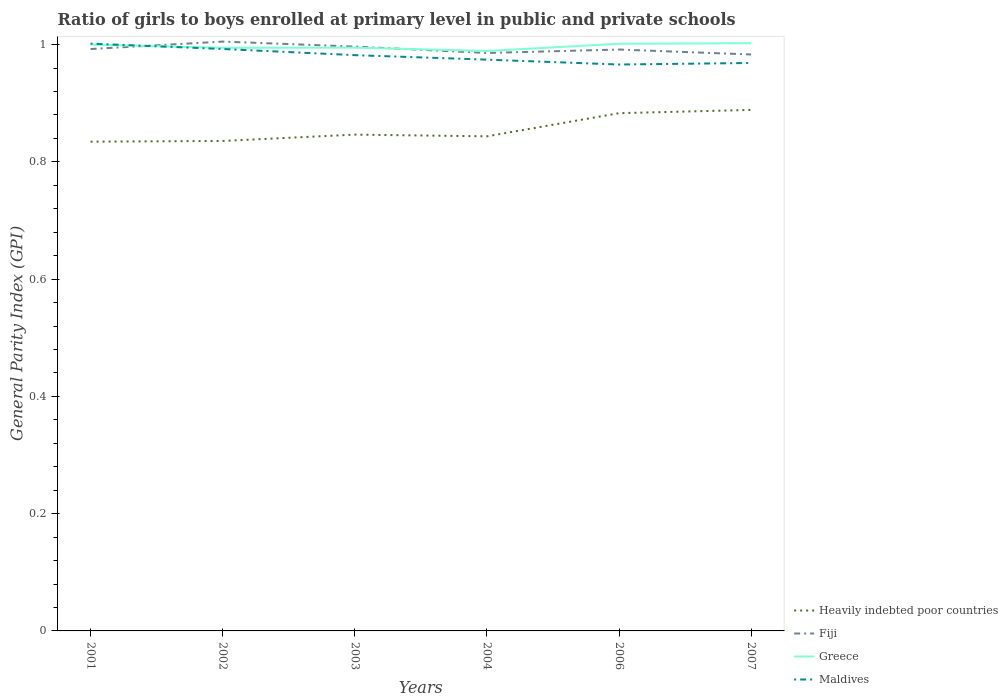Does the line corresponding to Maldives intersect with the line corresponding to Heavily indebted poor countries?
Provide a short and direct response. No. Is the number of lines equal to the number of legend labels?
Your answer should be very brief. Yes. Across all years, what is the maximum general parity index in Maldives?
Offer a very short reply. 0.97. What is the total general parity index in Heavily indebted poor countries in the graph?
Your answer should be compact. -0.01. What is the difference between the highest and the second highest general parity index in Fiji?
Offer a terse response. 0.02. What is the difference between two consecutive major ticks on the Y-axis?
Your answer should be very brief. 0.2. Does the graph contain any zero values?
Make the answer very short. No. Does the graph contain grids?
Offer a very short reply. No. Where does the legend appear in the graph?
Make the answer very short. Bottom right. How many legend labels are there?
Keep it short and to the point. 4. What is the title of the graph?
Provide a succinct answer. Ratio of girls to boys enrolled at primary level in public and private schools. Does "Saudi Arabia" appear as one of the legend labels in the graph?
Keep it short and to the point. No. What is the label or title of the Y-axis?
Your response must be concise. General Parity Index (GPI). What is the General Parity Index (GPI) of Heavily indebted poor countries in 2001?
Provide a succinct answer. 0.83. What is the General Parity Index (GPI) in Fiji in 2001?
Keep it short and to the point. 0.99. What is the General Parity Index (GPI) in Greece in 2001?
Provide a short and direct response. 1. What is the General Parity Index (GPI) in Maldives in 2001?
Provide a succinct answer. 1. What is the General Parity Index (GPI) of Heavily indebted poor countries in 2002?
Ensure brevity in your answer.  0.84. What is the General Parity Index (GPI) of Fiji in 2002?
Provide a succinct answer. 1.01. What is the General Parity Index (GPI) of Greece in 2002?
Your response must be concise. 0.99. What is the General Parity Index (GPI) of Maldives in 2002?
Your answer should be very brief. 0.99. What is the General Parity Index (GPI) of Heavily indebted poor countries in 2003?
Keep it short and to the point. 0.85. What is the General Parity Index (GPI) of Fiji in 2003?
Provide a short and direct response. 1. What is the General Parity Index (GPI) in Greece in 2003?
Provide a short and direct response. 0.99. What is the General Parity Index (GPI) of Maldives in 2003?
Provide a short and direct response. 0.98. What is the General Parity Index (GPI) of Heavily indebted poor countries in 2004?
Make the answer very short. 0.84. What is the General Parity Index (GPI) in Fiji in 2004?
Provide a succinct answer. 0.99. What is the General Parity Index (GPI) in Greece in 2004?
Provide a succinct answer. 0.99. What is the General Parity Index (GPI) of Maldives in 2004?
Your answer should be compact. 0.97. What is the General Parity Index (GPI) of Heavily indebted poor countries in 2006?
Your answer should be compact. 0.88. What is the General Parity Index (GPI) in Fiji in 2006?
Your answer should be very brief. 0.99. What is the General Parity Index (GPI) in Greece in 2006?
Provide a short and direct response. 1. What is the General Parity Index (GPI) of Maldives in 2006?
Offer a very short reply. 0.97. What is the General Parity Index (GPI) in Heavily indebted poor countries in 2007?
Provide a succinct answer. 0.89. What is the General Parity Index (GPI) in Fiji in 2007?
Your response must be concise. 0.98. What is the General Parity Index (GPI) in Greece in 2007?
Give a very brief answer. 1. What is the General Parity Index (GPI) of Maldives in 2007?
Give a very brief answer. 0.97. Across all years, what is the maximum General Parity Index (GPI) in Heavily indebted poor countries?
Offer a terse response. 0.89. Across all years, what is the maximum General Parity Index (GPI) of Fiji?
Your answer should be compact. 1.01. Across all years, what is the maximum General Parity Index (GPI) of Greece?
Offer a very short reply. 1. Across all years, what is the maximum General Parity Index (GPI) of Maldives?
Your response must be concise. 1. Across all years, what is the minimum General Parity Index (GPI) of Heavily indebted poor countries?
Make the answer very short. 0.83. Across all years, what is the minimum General Parity Index (GPI) of Fiji?
Provide a succinct answer. 0.98. Across all years, what is the minimum General Parity Index (GPI) in Greece?
Give a very brief answer. 0.99. Across all years, what is the minimum General Parity Index (GPI) of Maldives?
Give a very brief answer. 0.97. What is the total General Parity Index (GPI) in Heavily indebted poor countries in the graph?
Keep it short and to the point. 5.13. What is the total General Parity Index (GPI) in Fiji in the graph?
Offer a terse response. 5.95. What is the total General Parity Index (GPI) of Greece in the graph?
Make the answer very short. 5.98. What is the total General Parity Index (GPI) of Maldives in the graph?
Provide a short and direct response. 5.89. What is the difference between the General Parity Index (GPI) of Heavily indebted poor countries in 2001 and that in 2002?
Offer a very short reply. -0. What is the difference between the General Parity Index (GPI) in Fiji in 2001 and that in 2002?
Your answer should be very brief. -0.01. What is the difference between the General Parity Index (GPI) in Greece in 2001 and that in 2002?
Ensure brevity in your answer.  0.01. What is the difference between the General Parity Index (GPI) of Maldives in 2001 and that in 2002?
Provide a succinct answer. 0.01. What is the difference between the General Parity Index (GPI) of Heavily indebted poor countries in 2001 and that in 2003?
Offer a terse response. -0.01. What is the difference between the General Parity Index (GPI) in Fiji in 2001 and that in 2003?
Your answer should be very brief. -0. What is the difference between the General Parity Index (GPI) of Greece in 2001 and that in 2003?
Provide a succinct answer. 0.01. What is the difference between the General Parity Index (GPI) in Maldives in 2001 and that in 2003?
Your answer should be compact. 0.02. What is the difference between the General Parity Index (GPI) of Heavily indebted poor countries in 2001 and that in 2004?
Provide a succinct answer. -0.01. What is the difference between the General Parity Index (GPI) in Fiji in 2001 and that in 2004?
Your answer should be very brief. 0.01. What is the difference between the General Parity Index (GPI) in Greece in 2001 and that in 2004?
Provide a succinct answer. 0.01. What is the difference between the General Parity Index (GPI) of Maldives in 2001 and that in 2004?
Provide a short and direct response. 0.03. What is the difference between the General Parity Index (GPI) of Heavily indebted poor countries in 2001 and that in 2006?
Give a very brief answer. -0.05. What is the difference between the General Parity Index (GPI) in Fiji in 2001 and that in 2006?
Offer a very short reply. 0. What is the difference between the General Parity Index (GPI) in Greece in 2001 and that in 2006?
Provide a succinct answer. -0. What is the difference between the General Parity Index (GPI) of Maldives in 2001 and that in 2006?
Your answer should be very brief. 0.04. What is the difference between the General Parity Index (GPI) of Heavily indebted poor countries in 2001 and that in 2007?
Provide a short and direct response. -0.05. What is the difference between the General Parity Index (GPI) of Fiji in 2001 and that in 2007?
Provide a succinct answer. 0.01. What is the difference between the General Parity Index (GPI) in Greece in 2001 and that in 2007?
Provide a succinct answer. -0. What is the difference between the General Parity Index (GPI) in Maldives in 2001 and that in 2007?
Provide a short and direct response. 0.03. What is the difference between the General Parity Index (GPI) in Heavily indebted poor countries in 2002 and that in 2003?
Offer a terse response. -0.01. What is the difference between the General Parity Index (GPI) in Fiji in 2002 and that in 2003?
Ensure brevity in your answer.  0.01. What is the difference between the General Parity Index (GPI) in Greece in 2002 and that in 2003?
Provide a succinct answer. -0. What is the difference between the General Parity Index (GPI) in Maldives in 2002 and that in 2003?
Provide a short and direct response. 0.01. What is the difference between the General Parity Index (GPI) of Heavily indebted poor countries in 2002 and that in 2004?
Offer a very short reply. -0.01. What is the difference between the General Parity Index (GPI) of Fiji in 2002 and that in 2004?
Your response must be concise. 0.02. What is the difference between the General Parity Index (GPI) of Greece in 2002 and that in 2004?
Make the answer very short. 0.01. What is the difference between the General Parity Index (GPI) in Maldives in 2002 and that in 2004?
Make the answer very short. 0.02. What is the difference between the General Parity Index (GPI) in Heavily indebted poor countries in 2002 and that in 2006?
Your response must be concise. -0.05. What is the difference between the General Parity Index (GPI) in Fiji in 2002 and that in 2006?
Offer a very short reply. 0.01. What is the difference between the General Parity Index (GPI) in Greece in 2002 and that in 2006?
Make the answer very short. -0.01. What is the difference between the General Parity Index (GPI) in Maldives in 2002 and that in 2006?
Your response must be concise. 0.03. What is the difference between the General Parity Index (GPI) of Heavily indebted poor countries in 2002 and that in 2007?
Keep it short and to the point. -0.05. What is the difference between the General Parity Index (GPI) of Fiji in 2002 and that in 2007?
Provide a succinct answer. 0.02. What is the difference between the General Parity Index (GPI) in Greece in 2002 and that in 2007?
Keep it short and to the point. -0.01. What is the difference between the General Parity Index (GPI) in Maldives in 2002 and that in 2007?
Provide a succinct answer. 0.02. What is the difference between the General Parity Index (GPI) in Heavily indebted poor countries in 2003 and that in 2004?
Give a very brief answer. 0. What is the difference between the General Parity Index (GPI) in Fiji in 2003 and that in 2004?
Ensure brevity in your answer.  0.01. What is the difference between the General Parity Index (GPI) in Greece in 2003 and that in 2004?
Offer a terse response. 0.01. What is the difference between the General Parity Index (GPI) in Maldives in 2003 and that in 2004?
Your response must be concise. 0.01. What is the difference between the General Parity Index (GPI) of Heavily indebted poor countries in 2003 and that in 2006?
Ensure brevity in your answer.  -0.04. What is the difference between the General Parity Index (GPI) of Fiji in 2003 and that in 2006?
Your answer should be very brief. 0.01. What is the difference between the General Parity Index (GPI) of Greece in 2003 and that in 2006?
Give a very brief answer. -0.01. What is the difference between the General Parity Index (GPI) of Maldives in 2003 and that in 2006?
Your answer should be compact. 0.02. What is the difference between the General Parity Index (GPI) in Heavily indebted poor countries in 2003 and that in 2007?
Make the answer very short. -0.04. What is the difference between the General Parity Index (GPI) of Fiji in 2003 and that in 2007?
Your answer should be very brief. 0.01. What is the difference between the General Parity Index (GPI) of Greece in 2003 and that in 2007?
Keep it short and to the point. -0.01. What is the difference between the General Parity Index (GPI) in Maldives in 2003 and that in 2007?
Give a very brief answer. 0.01. What is the difference between the General Parity Index (GPI) in Heavily indebted poor countries in 2004 and that in 2006?
Make the answer very short. -0.04. What is the difference between the General Parity Index (GPI) in Fiji in 2004 and that in 2006?
Offer a terse response. -0.01. What is the difference between the General Parity Index (GPI) in Greece in 2004 and that in 2006?
Make the answer very short. -0.01. What is the difference between the General Parity Index (GPI) of Maldives in 2004 and that in 2006?
Your answer should be very brief. 0.01. What is the difference between the General Parity Index (GPI) in Heavily indebted poor countries in 2004 and that in 2007?
Offer a terse response. -0.05. What is the difference between the General Parity Index (GPI) in Fiji in 2004 and that in 2007?
Offer a very short reply. 0. What is the difference between the General Parity Index (GPI) of Greece in 2004 and that in 2007?
Your answer should be very brief. -0.01. What is the difference between the General Parity Index (GPI) of Maldives in 2004 and that in 2007?
Your response must be concise. 0.01. What is the difference between the General Parity Index (GPI) in Heavily indebted poor countries in 2006 and that in 2007?
Offer a very short reply. -0.01. What is the difference between the General Parity Index (GPI) in Fiji in 2006 and that in 2007?
Make the answer very short. 0.01. What is the difference between the General Parity Index (GPI) of Greece in 2006 and that in 2007?
Offer a terse response. -0. What is the difference between the General Parity Index (GPI) in Maldives in 2006 and that in 2007?
Provide a short and direct response. -0. What is the difference between the General Parity Index (GPI) of Heavily indebted poor countries in 2001 and the General Parity Index (GPI) of Fiji in 2002?
Make the answer very short. -0.17. What is the difference between the General Parity Index (GPI) in Heavily indebted poor countries in 2001 and the General Parity Index (GPI) in Greece in 2002?
Give a very brief answer. -0.16. What is the difference between the General Parity Index (GPI) in Heavily indebted poor countries in 2001 and the General Parity Index (GPI) in Maldives in 2002?
Offer a very short reply. -0.16. What is the difference between the General Parity Index (GPI) of Fiji in 2001 and the General Parity Index (GPI) of Greece in 2002?
Offer a terse response. -0. What is the difference between the General Parity Index (GPI) in Fiji in 2001 and the General Parity Index (GPI) in Maldives in 2002?
Provide a short and direct response. -0. What is the difference between the General Parity Index (GPI) in Greece in 2001 and the General Parity Index (GPI) in Maldives in 2002?
Provide a short and direct response. 0.01. What is the difference between the General Parity Index (GPI) in Heavily indebted poor countries in 2001 and the General Parity Index (GPI) in Fiji in 2003?
Offer a terse response. -0.16. What is the difference between the General Parity Index (GPI) in Heavily indebted poor countries in 2001 and the General Parity Index (GPI) in Greece in 2003?
Provide a short and direct response. -0.16. What is the difference between the General Parity Index (GPI) of Heavily indebted poor countries in 2001 and the General Parity Index (GPI) of Maldives in 2003?
Ensure brevity in your answer.  -0.15. What is the difference between the General Parity Index (GPI) of Fiji in 2001 and the General Parity Index (GPI) of Greece in 2003?
Offer a very short reply. -0. What is the difference between the General Parity Index (GPI) in Fiji in 2001 and the General Parity Index (GPI) in Maldives in 2003?
Offer a very short reply. 0.01. What is the difference between the General Parity Index (GPI) in Greece in 2001 and the General Parity Index (GPI) in Maldives in 2003?
Keep it short and to the point. 0.02. What is the difference between the General Parity Index (GPI) of Heavily indebted poor countries in 2001 and the General Parity Index (GPI) of Fiji in 2004?
Give a very brief answer. -0.15. What is the difference between the General Parity Index (GPI) in Heavily indebted poor countries in 2001 and the General Parity Index (GPI) in Greece in 2004?
Keep it short and to the point. -0.15. What is the difference between the General Parity Index (GPI) of Heavily indebted poor countries in 2001 and the General Parity Index (GPI) of Maldives in 2004?
Provide a succinct answer. -0.14. What is the difference between the General Parity Index (GPI) of Fiji in 2001 and the General Parity Index (GPI) of Greece in 2004?
Make the answer very short. 0. What is the difference between the General Parity Index (GPI) in Fiji in 2001 and the General Parity Index (GPI) in Maldives in 2004?
Your answer should be very brief. 0.02. What is the difference between the General Parity Index (GPI) of Greece in 2001 and the General Parity Index (GPI) of Maldives in 2004?
Ensure brevity in your answer.  0.03. What is the difference between the General Parity Index (GPI) of Heavily indebted poor countries in 2001 and the General Parity Index (GPI) of Fiji in 2006?
Provide a succinct answer. -0.16. What is the difference between the General Parity Index (GPI) of Heavily indebted poor countries in 2001 and the General Parity Index (GPI) of Greece in 2006?
Your response must be concise. -0.17. What is the difference between the General Parity Index (GPI) of Heavily indebted poor countries in 2001 and the General Parity Index (GPI) of Maldives in 2006?
Offer a terse response. -0.13. What is the difference between the General Parity Index (GPI) of Fiji in 2001 and the General Parity Index (GPI) of Greece in 2006?
Make the answer very short. -0.01. What is the difference between the General Parity Index (GPI) in Fiji in 2001 and the General Parity Index (GPI) in Maldives in 2006?
Provide a succinct answer. 0.03. What is the difference between the General Parity Index (GPI) in Greece in 2001 and the General Parity Index (GPI) in Maldives in 2006?
Keep it short and to the point. 0.03. What is the difference between the General Parity Index (GPI) of Heavily indebted poor countries in 2001 and the General Parity Index (GPI) of Fiji in 2007?
Your answer should be very brief. -0.15. What is the difference between the General Parity Index (GPI) in Heavily indebted poor countries in 2001 and the General Parity Index (GPI) in Greece in 2007?
Provide a succinct answer. -0.17. What is the difference between the General Parity Index (GPI) of Heavily indebted poor countries in 2001 and the General Parity Index (GPI) of Maldives in 2007?
Your answer should be compact. -0.13. What is the difference between the General Parity Index (GPI) of Fiji in 2001 and the General Parity Index (GPI) of Greece in 2007?
Offer a very short reply. -0.01. What is the difference between the General Parity Index (GPI) in Fiji in 2001 and the General Parity Index (GPI) in Maldives in 2007?
Give a very brief answer. 0.02. What is the difference between the General Parity Index (GPI) of Greece in 2001 and the General Parity Index (GPI) of Maldives in 2007?
Keep it short and to the point. 0.03. What is the difference between the General Parity Index (GPI) in Heavily indebted poor countries in 2002 and the General Parity Index (GPI) in Fiji in 2003?
Keep it short and to the point. -0.16. What is the difference between the General Parity Index (GPI) of Heavily indebted poor countries in 2002 and the General Parity Index (GPI) of Greece in 2003?
Offer a terse response. -0.16. What is the difference between the General Parity Index (GPI) of Heavily indebted poor countries in 2002 and the General Parity Index (GPI) of Maldives in 2003?
Offer a terse response. -0.15. What is the difference between the General Parity Index (GPI) in Fiji in 2002 and the General Parity Index (GPI) in Greece in 2003?
Offer a terse response. 0.01. What is the difference between the General Parity Index (GPI) of Fiji in 2002 and the General Parity Index (GPI) of Maldives in 2003?
Your answer should be very brief. 0.02. What is the difference between the General Parity Index (GPI) in Greece in 2002 and the General Parity Index (GPI) in Maldives in 2003?
Offer a very short reply. 0.01. What is the difference between the General Parity Index (GPI) in Heavily indebted poor countries in 2002 and the General Parity Index (GPI) in Fiji in 2004?
Your answer should be very brief. -0.15. What is the difference between the General Parity Index (GPI) in Heavily indebted poor countries in 2002 and the General Parity Index (GPI) in Greece in 2004?
Give a very brief answer. -0.15. What is the difference between the General Parity Index (GPI) in Heavily indebted poor countries in 2002 and the General Parity Index (GPI) in Maldives in 2004?
Ensure brevity in your answer.  -0.14. What is the difference between the General Parity Index (GPI) of Fiji in 2002 and the General Parity Index (GPI) of Greece in 2004?
Make the answer very short. 0.02. What is the difference between the General Parity Index (GPI) of Fiji in 2002 and the General Parity Index (GPI) of Maldives in 2004?
Provide a short and direct response. 0.03. What is the difference between the General Parity Index (GPI) in Greece in 2002 and the General Parity Index (GPI) in Maldives in 2004?
Ensure brevity in your answer.  0.02. What is the difference between the General Parity Index (GPI) of Heavily indebted poor countries in 2002 and the General Parity Index (GPI) of Fiji in 2006?
Offer a terse response. -0.16. What is the difference between the General Parity Index (GPI) in Heavily indebted poor countries in 2002 and the General Parity Index (GPI) in Greece in 2006?
Provide a succinct answer. -0.17. What is the difference between the General Parity Index (GPI) of Heavily indebted poor countries in 2002 and the General Parity Index (GPI) of Maldives in 2006?
Provide a succinct answer. -0.13. What is the difference between the General Parity Index (GPI) of Fiji in 2002 and the General Parity Index (GPI) of Greece in 2006?
Offer a very short reply. 0. What is the difference between the General Parity Index (GPI) of Fiji in 2002 and the General Parity Index (GPI) of Maldives in 2006?
Offer a very short reply. 0.04. What is the difference between the General Parity Index (GPI) of Greece in 2002 and the General Parity Index (GPI) of Maldives in 2006?
Ensure brevity in your answer.  0.03. What is the difference between the General Parity Index (GPI) in Heavily indebted poor countries in 2002 and the General Parity Index (GPI) in Fiji in 2007?
Offer a terse response. -0.15. What is the difference between the General Parity Index (GPI) of Heavily indebted poor countries in 2002 and the General Parity Index (GPI) of Maldives in 2007?
Your answer should be very brief. -0.13. What is the difference between the General Parity Index (GPI) in Fiji in 2002 and the General Parity Index (GPI) in Greece in 2007?
Provide a short and direct response. 0. What is the difference between the General Parity Index (GPI) in Fiji in 2002 and the General Parity Index (GPI) in Maldives in 2007?
Provide a short and direct response. 0.04. What is the difference between the General Parity Index (GPI) of Greece in 2002 and the General Parity Index (GPI) of Maldives in 2007?
Your answer should be very brief. 0.03. What is the difference between the General Parity Index (GPI) in Heavily indebted poor countries in 2003 and the General Parity Index (GPI) in Fiji in 2004?
Ensure brevity in your answer.  -0.14. What is the difference between the General Parity Index (GPI) of Heavily indebted poor countries in 2003 and the General Parity Index (GPI) of Greece in 2004?
Ensure brevity in your answer.  -0.14. What is the difference between the General Parity Index (GPI) in Heavily indebted poor countries in 2003 and the General Parity Index (GPI) in Maldives in 2004?
Keep it short and to the point. -0.13. What is the difference between the General Parity Index (GPI) of Fiji in 2003 and the General Parity Index (GPI) of Greece in 2004?
Give a very brief answer. 0.01. What is the difference between the General Parity Index (GPI) of Fiji in 2003 and the General Parity Index (GPI) of Maldives in 2004?
Offer a terse response. 0.02. What is the difference between the General Parity Index (GPI) of Greece in 2003 and the General Parity Index (GPI) of Maldives in 2004?
Your answer should be very brief. 0.02. What is the difference between the General Parity Index (GPI) in Heavily indebted poor countries in 2003 and the General Parity Index (GPI) in Fiji in 2006?
Keep it short and to the point. -0.15. What is the difference between the General Parity Index (GPI) in Heavily indebted poor countries in 2003 and the General Parity Index (GPI) in Greece in 2006?
Your answer should be very brief. -0.15. What is the difference between the General Parity Index (GPI) in Heavily indebted poor countries in 2003 and the General Parity Index (GPI) in Maldives in 2006?
Provide a succinct answer. -0.12. What is the difference between the General Parity Index (GPI) in Fiji in 2003 and the General Parity Index (GPI) in Greece in 2006?
Your response must be concise. -0. What is the difference between the General Parity Index (GPI) of Fiji in 2003 and the General Parity Index (GPI) of Maldives in 2006?
Your answer should be very brief. 0.03. What is the difference between the General Parity Index (GPI) in Greece in 2003 and the General Parity Index (GPI) in Maldives in 2006?
Ensure brevity in your answer.  0.03. What is the difference between the General Parity Index (GPI) in Heavily indebted poor countries in 2003 and the General Parity Index (GPI) in Fiji in 2007?
Ensure brevity in your answer.  -0.14. What is the difference between the General Parity Index (GPI) in Heavily indebted poor countries in 2003 and the General Parity Index (GPI) in Greece in 2007?
Ensure brevity in your answer.  -0.16. What is the difference between the General Parity Index (GPI) in Heavily indebted poor countries in 2003 and the General Parity Index (GPI) in Maldives in 2007?
Offer a very short reply. -0.12. What is the difference between the General Parity Index (GPI) in Fiji in 2003 and the General Parity Index (GPI) in Greece in 2007?
Offer a terse response. -0.01. What is the difference between the General Parity Index (GPI) in Fiji in 2003 and the General Parity Index (GPI) in Maldives in 2007?
Offer a very short reply. 0.03. What is the difference between the General Parity Index (GPI) of Greece in 2003 and the General Parity Index (GPI) of Maldives in 2007?
Make the answer very short. 0.03. What is the difference between the General Parity Index (GPI) of Heavily indebted poor countries in 2004 and the General Parity Index (GPI) of Fiji in 2006?
Give a very brief answer. -0.15. What is the difference between the General Parity Index (GPI) in Heavily indebted poor countries in 2004 and the General Parity Index (GPI) in Greece in 2006?
Give a very brief answer. -0.16. What is the difference between the General Parity Index (GPI) of Heavily indebted poor countries in 2004 and the General Parity Index (GPI) of Maldives in 2006?
Your answer should be very brief. -0.12. What is the difference between the General Parity Index (GPI) of Fiji in 2004 and the General Parity Index (GPI) of Greece in 2006?
Keep it short and to the point. -0.02. What is the difference between the General Parity Index (GPI) of Fiji in 2004 and the General Parity Index (GPI) of Maldives in 2006?
Keep it short and to the point. 0.02. What is the difference between the General Parity Index (GPI) in Greece in 2004 and the General Parity Index (GPI) in Maldives in 2006?
Your response must be concise. 0.02. What is the difference between the General Parity Index (GPI) of Heavily indebted poor countries in 2004 and the General Parity Index (GPI) of Fiji in 2007?
Provide a succinct answer. -0.14. What is the difference between the General Parity Index (GPI) in Heavily indebted poor countries in 2004 and the General Parity Index (GPI) in Greece in 2007?
Your answer should be very brief. -0.16. What is the difference between the General Parity Index (GPI) of Heavily indebted poor countries in 2004 and the General Parity Index (GPI) of Maldives in 2007?
Your answer should be compact. -0.13. What is the difference between the General Parity Index (GPI) of Fiji in 2004 and the General Parity Index (GPI) of Greece in 2007?
Keep it short and to the point. -0.02. What is the difference between the General Parity Index (GPI) in Fiji in 2004 and the General Parity Index (GPI) in Maldives in 2007?
Your answer should be compact. 0.02. What is the difference between the General Parity Index (GPI) of Greece in 2004 and the General Parity Index (GPI) of Maldives in 2007?
Offer a very short reply. 0.02. What is the difference between the General Parity Index (GPI) in Heavily indebted poor countries in 2006 and the General Parity Index (GPI) in Fiji in 2007?
Keep it short and to the point. -0.1. What is the difference between the General Parity Index (GPI) of Heavily indebted poor countries in 2006 and the General Parity Index (GPI) of Greece in 2007?
Offer a very short reply. -0.12. What is the difference between the General Parity Index (GPI) of Heavily indebted poor countries in 2006 and the General Parity Index (GPI) of Maldives in 2007?
Provide a succinct answer. -0.09. What is the difference between the General Parity Index (GPI) of Fiji in 2006 and the General Parity Index (GPI) of Greece in 2007?
Give a very brief answer. -0.01. What is the difference between the General Parity Index (GPI) in Fiji in 2006 and the General Parity Index (GPI) in Maldives in 2007?
Your answer should be compact. 0.02. What is the difference between the General Parity Index (GPI) of Greece in 2006 and the General Parity Index (GPI) of Maldives in 2007?
Offer a very short reply. 0.03. What is the average General Parity Index (GPI) of Heavily indebted poor countries per year?
Provide a short and direct response. 0.86. What is the average General Parity Index (GPI) of Fiji per year?
Provide a succinct answer. 0.99. What is the average General Parity Index (GPI) of Greece per year?
Your answer should be very brief. 1. What is the average General Parity Index (GPI) of Maldives per year?
Provide a succinct answer. 0.98. In the year 2001, what is the difference between the General Parity Index (GPI) in Heavily indebted poor countries and General Parity Index (GPI) in Fiji?
Your answer should be very brief. -0.16. In the year 2001, what is the difference between the General Parity Index (GPI) in Heavily indebted poor countries and General Parity Index (GPI) in Greece?
Provide a short and direct response. -0.17. In the year 2001, what is the difference between the General Parity Index (GPI) of Heavily indebted poor countries and General Parity Index (GPI) of Maldives?
Provide a succinct answer. -0.17. In the year 2001, what is the difference between the General Parity Index (GPI) in Fiji and General Parity Index (GPI) in Greece?
Give a very brief answer. -0.01. In the year 2001, what is the difference between the General Parity Index (GPI) in Fiji and General Parity Index (GPI) in Maldives?
Your response must be concise. -0.01. In the year 2001, what is the difference between the General Parity Index (GPI) of Greece and General Parity Index (GPI) of Maldives?
Provide a succinct answer. -0. In the year 2002, what is the difference between the General Parity Index (GPI) of Heavily indebted poor countries and General Parity Index (GPI) of Fiji?
Keep it short and to the point. -0.17. In the year 2002, what is the difference between the General Parity Index (GPI) of Heavily indebted poor countries and General Parity Index (GPI) of Greece?
Offer a terse response. -0.16. In the year 2002, what is the difference between the General Parity Index (GPI) of Heavily indebted poor countries and General Parity Index (GPI) of Maldives?
Your answer should be compact. -0.16. In the year 2002, what is the difference between the General Parity Index (GPI) of Fiji and General Parity Index (GPI) of Greece?
Your answer should be compact. 0.01. In the year 2002, what is the difference between the General Parity Index (GPI) in Fiji and General Parity Index (GPI) in Maldives?
Provide a succinct answer. 0.01. In the year 2002, what is the difference between the General Parity Index (GPI) of Greece and General Parity Index (GPI) of Maldives?
Keep it short and to the point. 0. In the year 2003, what is the difference between the General Parity Index (GPI) of Heavily indebted poor countries and General Parity Index (GPI) of Fiji?
Keep it short and to the point. -0.15. In the year 2003, what is the difference between the General Parity Index (GPI) of Heavily indebted poor countries and General Parity Index (GPI) of Greece?
Your answer should be very brief. -0.15. In the year 2003, what is the difference between the General Parity Index (GPI) in Heavily indebted poor countries and General Parity Index (GPI) in Maldives?
Ensure brevity in your answer.  -0.14. In the year 2003, what is the difference between the General Parity Index (GPI) of Fiji and General Parity Index (GPI) of Greece?
Offer a terse response. 0. In the year 2003, what is the difference between the General Parity Index (GPI) in Fiji and General Parity Index (GPI) in Maldives?
Your response must be concise. 0.01. In the year 2003, what is the difference between the General Parity Index (GPI) in Greece and General Parity Index (GPI) in Maldives?
Your answer should be compact. 0.01. In the year 2004, what is the difference between the General Parity Index (GPI) in Heavily indebted poor countries and General Parity Index (GPI) in Fiji?
Keep it short and to the point. -0.14. In the year 2004, what is the difference between the General Parity Index (GPI) in Heavily indebted poor countries and General Parity Index (GPI) in Greece?
Give a very brief answer. -0.15. In the year 2004, what is the difference between the General Parity Index (GPI) of Heavily indebted poor countries and General Parity Index (GPI) of Maldives?
Offer a very short reply. -0.13. In the year 2004, what is the difference between the General Parity Index (GPI) in Fiji and General Parity Index (GPI) in Greece?
Provide a succinct answer. -0. In the year 2004, what is the difference between the General Parity Index (GPI) in Fiji and General Parity Index (GPI) in Maldives?
Give a very brief answer. 0.01. In the year 2004, what is the difference between the General Parity Index (GPI) in Greece and General Parity Index (GPI) in Maldives?
Offer a terse response. 0.01. In the year 2006, what is the difference between the General Parity Index (GPI) of Heavily indebted poor countries and General Parity Index (GPI) of Fiji?
Your answer should be very brief. -0.11. In the year 2006, what is the difference between the General Parity Index (GPI) of Heavily indebted poor countries and General Parity Index (GPI) of Greece?
Ensure brevity in your answer.  -0.12. In the year 2006, what is the difference between the General Parity Index (GPI) in Heavily indebted poor countries and General Parity Index (GPI) in Maldives?
Give a very brief answer. -0.08. In the year 2006, what is the difference between the General Parity Index (GPI) of Fiji and General Parity Index (GPI) of Greece?
Your answer should be very brief. -0.01. In the year 2006, what is the difference between the General Parity Index (GPI) of Fiji and General Parity Index (GPI) of Maldives?
Your response must be concise. 0.03. In the year 2006, what is the difference between the General Parity Index (GPI) of Greece and General Parity Index (GPI) of Maldives?
Make the answer very short. 0.04. In the year 2007, what is the difference between the General Parity Index (GPI) of Heavily indebted poor countries and General Parity Index (GPI) of Fiji?
Provide a short and direct response. -0.09. In the year 2007, what is the difference between the General Parity Index (GPI) of Heavily indebted poor countries and General Parity Index (GPI) of Greece?
Offer a terse response. -0.11. In the year 2007, what is the difference between the General Parity Index (GPI) of Heavily indebted poor countries and General Parity Index (GPI) of Maldives?
Ensure brevity in your answer.  -0.08. In the year 2007, what is the difference between the General Parity Index (GPI) in Fiji and General Parity Index (GPI) in Greece?
Keep it short and to the point. -0.02. In the year 2007, what is the difference between the General Parity Index (GPI) of Fiji and General Parity Index (GPI) of Maldives?
Your response must be concise. 0.01. In the year 2007, what is the difference between the General Parity Index (GPI) in Greece and General Parity Index (GPI) in Maldives?
Offer a very short reply. 0.03. What is the ratio of the General Parity Index (GPI) in Fiji in 2001 to that in 2002?
Provide a short and direct response. 0.99. What is the ratio of the General Parity Index (GPI) of Maldives in 2001 to that in 2002?
Offer a terse response. 1.01. What is the ratio of the General Parity Index (GPI) in Heavily indebted poor countries in 2001 to that in 2003?
Give a very brief answer. 0.99. What is the ratio of the General Parity Index (GPI) in Fiji in 2001 to that in 2004?
Your response must be concise. 1.01. What is the ratio of the General Parity Index (GPI) in Greece in 2001 to that in 2004?
Provide a short and direct response. 1.01. What is the ratio of the General Parity Index (GPI) of Maldives in 2001 to that in 2004?
Your answer should be compact. 1.03. What is the ratio of the General Parity Index (GPI) in Heavily indebted poor countries in 2001 to that in 2006?
Provide a short and direct response. 0.94. What is the ratio of the General Parity Index (GPI) in Maldives in 2001 to that in 2006?
Offer a terse response. 1.04. What is the ratio of the General Parity Index (GPI) of Heavily indebted poor countries in 2001 to that in 2007?
Ensure brevity in your answer.  0.94. What is the ratio of the General Parity Index (GPI) of Fiji in 2001 to that in 2007?
Ensure brevity in your answer.  1.01. What is the ratio of the General Parity Index (GPI) in Greece in 2001 to that in 2007?
Give a very brief answer. 1. What is the ratio of the General Parity Index (GPI) of Maldives in 2001 to that in 2007?
Give a very brief answer. 1.03. What is the ratio of the General Parity Index (GPI) in Heavily indebted poor countries in 2002 to that in 2003?
Your response must be concise. 0.99. What is the ratio of the General Parity Index (GPI) in Fiji in 2002 to that in 2003?
Provide a succinct answer. 1.01. What is the ratio of the General Parity Index (GPI) in Greece in 2002 to that in 2003?
Offer a terse response. 1. What is the ratio of the General Parity Index (GPI) of Maldives in 2002 to that in 2003?
Your answer should be compact. 1.01. What is the ratio of the General Parity Index (GPI) of Heavily indebted poor countries in 2002 to that in 2004?
Your answer should be compact. 0.99. What is the ratio of the General Parity Index (GPI) in Fiji in 2002 to that in 2004?
Keep it short and to the point. 1.02. What is the ratio of the General Parity Index (GPI) of Greece in 2002 to that in 2004?
Make the answer very short. 1.01. What is the ratio of the General Parity Index (GPI) in Maldives in 2002 to that in 2004?
Offer a very short reply. 1.02. What is the ratio of the General Parity Index (GPI) in Heavily indebted poor countries in 2002 to that in 2006?
Keep it short and to the point. 0.95. What is the ratio of the General Parity Index (GPI) in Fiji in 2002 to that in 2006?
Provide a succinct answer. 1.01. What is the ratio of the General Parity Index (GPI) in Maldives in 2002 to that in 2006?
Offer a terse response. 1.03. What is the ratio of the General Parity Index (GPI) in Heavily indebted poor countries in 2002 to that in 2007?
Provide a short and direct response. 0.94. What is the ratio of the General Parity Index (GPI) in Fiji in 2002 to that in 2007?
Your response must be concise. 1.02. What is the ratio of the General Parity Index (GPI) in Maldives in 2002 to that in 2007?
Make the answer very short. 1.02. What is the ratio of the General Parity Index (GPI) in Fiji in 2003 to that in 2004?
Offer a very short reply. 1.01. What is the ratio of the General Parity Index (GPI) of Greece in 2003 to that in 2004?
Give a very brief answer. 1.01. What is the ratio of the General Parity Index (GPI) in Maldives in 2003 to that in 2004?
Your response must be concise. 1.01. What is the ratio of the General Parity Index (GPI) of Heavily indebted poor countries in 2003 to that in 2006?
Provide a succinct answer. 0.96. What is the ratio of the General Parity Index (GPI) of Maldives in 2003 to that in 2006?
Keep it short and to the point. 1.02. What is the ratio of the General Parity Index (GPI) in Heavily indebted poor countries in 2003 to that in 2007?
Your response must be concise. 0.95. What is the ratio of the General Parity Index (GPI) in Fiji in 2003 to that in 2007?
Your answer should be very brief. 1.01. What is the ratio of the General Parity Index (GPI) of Greece in 2003 to that in 2007?
Your answer should be compact. 0.99. What is the ratio of the General Parity Index (GPI) in Maldives in 2003 to that in 2007?
Provide a short and direct response. 1.01. What is the ratio of the General Parity Index (GPI) in Heavily indebted poor countries in 2004 to that in 2006?
Offer a terse response. 0.96. What is the ratio of the General Parity Index (GPI) of Fiji in 2004 to that in 2006?
Provide a short and direct response. 0.99. What is the ratio of the General Parity Index (GPI) of Maldives in 2004 to that in 2006?
Make the answer very short. 1.01. What is the ratio of the General Parity Index (GPI) in Heavily indebted poor countries in 2004 to that in 2007?
Give a very brief answer. 0.95. What is the ratio of the General Parity Index (GPI) of Fiji in 2004 to that in 2007?
Offer a terse response. 1. What is the ratio of the General Parity Index (GPI) in Greece in 2004 to that in 2007?
Your response must be concise. 0.99. What is the ratio of the General Parity Index (GPI) in Maldives in 2004 to that in 2007?
Your answer should be compact. 1.01. What is the ratio of the General Parity Index (GPI) of Fiji in 2006 to that in 2007?
Provide a succinct answer. 1.01. What is the difference between the highest and the second highest General Parity Index (GPI) of Heavily indebted poor countries?
Your answer should be compact. 0.01. What is the difference between the highest and the second highest General Parity Index (GPI) of Fiji?
Provide a succinct answer. 0.01. What is the difference between the highest and the second highest General Parity Index (GPI) in Greece?
Your answer should be compact. 0. What is the difference between the highest and the second highest General Parity Index (GPI) in Maldives?
Your response must be concise. 0.01. What is the difference between the highest and the lowest General Parity Index (GPI) of Heavily indebted poor countries?
Make the answer very short. 0.05. What is the difference between the highest and the lowest General Parity Index (GPI) of Fiji?
Keep it short and to the point. 0.02. What is the difference between the highest and the lowest General Parity Index (GPI) of Greece?
Ensure brevity in your answer.  0.01. What is the difference between the highest and the lowest General Parity Index (GPI) in Maldives?
Offer a very short reply. 0.04. 